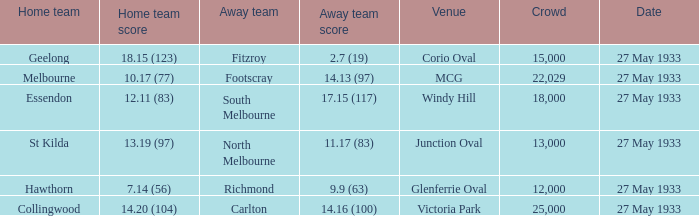20 (104), how many individuals were among the spectators? 25000.0. 